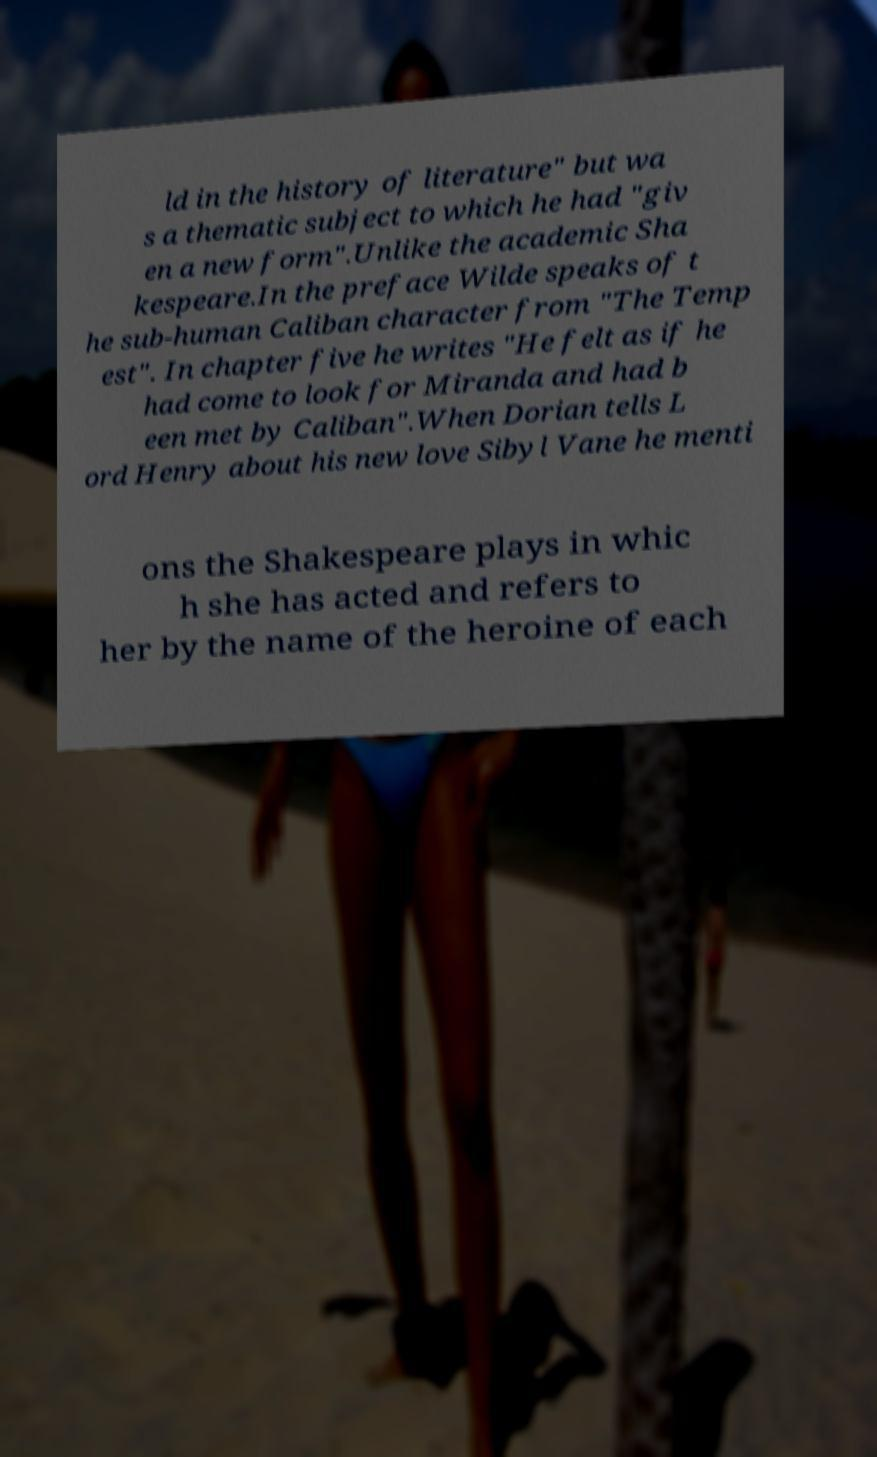Can you accurately transcribe the text from the provided image for me? ld in the history of literature" but wa s a thematic subject to which he had "giv en a new form".Unlike the academic Sha kespeare.In the preface Wilde speaks of t he sub-human Caliban character from "The Temp est". In chapter five he writes "He felt as if he had come to look for Miranda and had b een met by Caliban".When Dorian tells L ord Henry about his new love Sibyl Vane he menti ons the Shakespeare plays in whic h she has acted and refers to her by the name of the heroine of each 